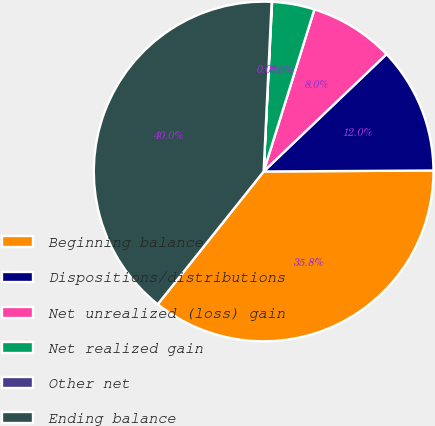Convert chart to OTSL. <chart><loc_0><loc_0><loc_500><loc_500><pie_chart><fcel>Beginning balance<fcel>Dispositions/distributions<fcel>Net unrealized (loss) gain<fcel>Net realized gain<fcel>Other net<fcel>Ending balance<nl><fcel>35.81%<fcel>12.04%<fcel>8.04%<fcel>4.04%<fcel>0.04%<fcel>40.04%<nl></chart> 